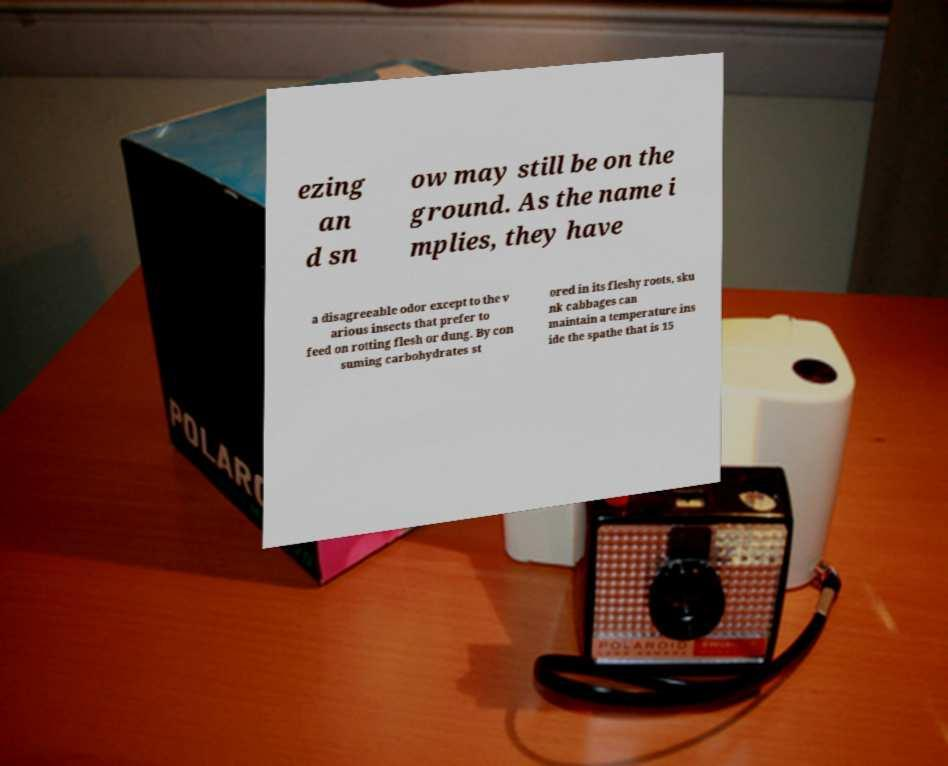Please identify and transcribe the text found in this image. ezing an d sn ow may still be on the ground. As the name i mplies, they have a disagreeable odor except to the v arious insects that prefer to feed on rotting flesh or dung. By con suming carbohydrates st ored in its fleshy roots, sku nk cabbages can maintain a temperature ins ide the spathe that is 15 